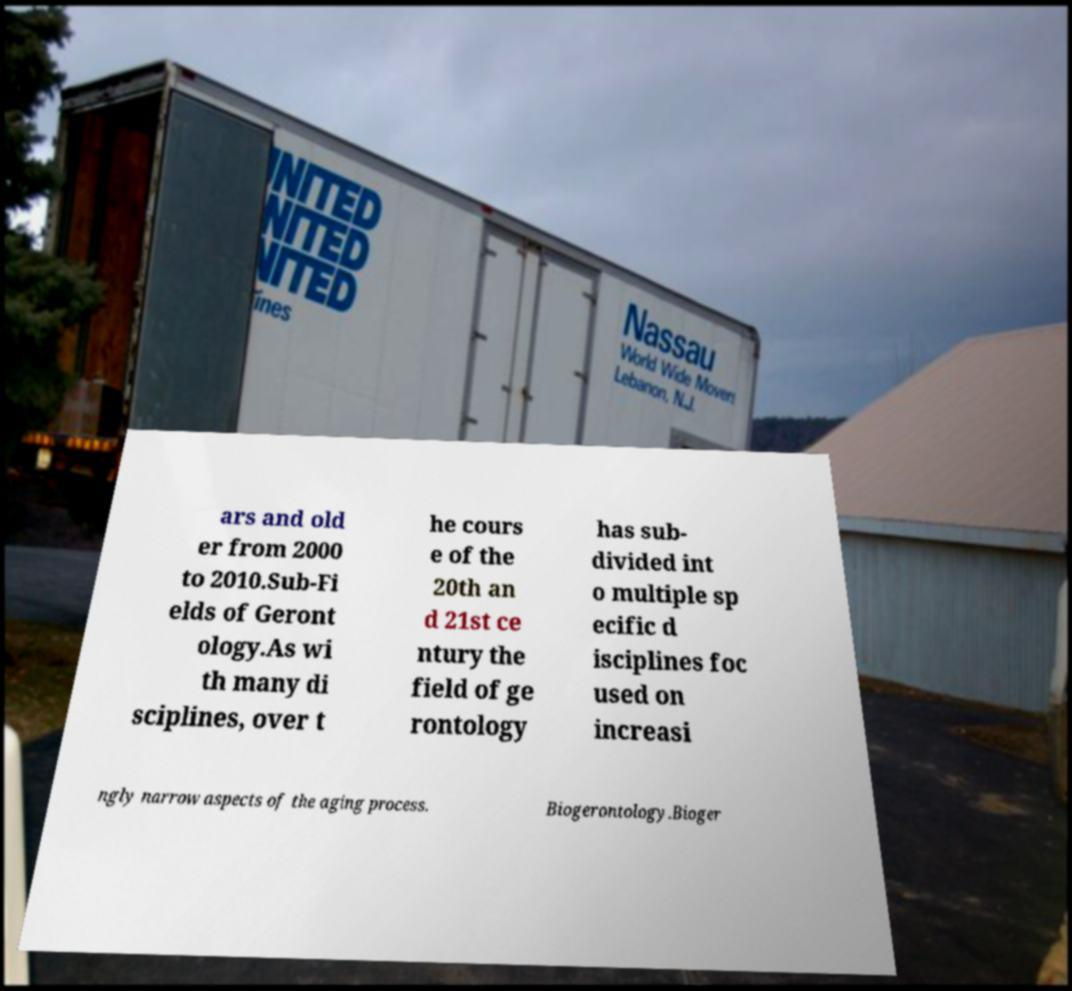Can you read and provide the text displayed in the image?This photo seems to have some interesting text. Can you extract and type it out for me? ars and old er from 2000 to 2010.Sub-Fi elds of Geront ology.As wi th many di sciplines, over t he cours e of the 20th an d 21st ce ntury the field of ge rontology has sub- divided int o multiple sp ecific d isciplines foc used on increasi ngly narrow aspects of the aging process. Biogerontology.Bioger 